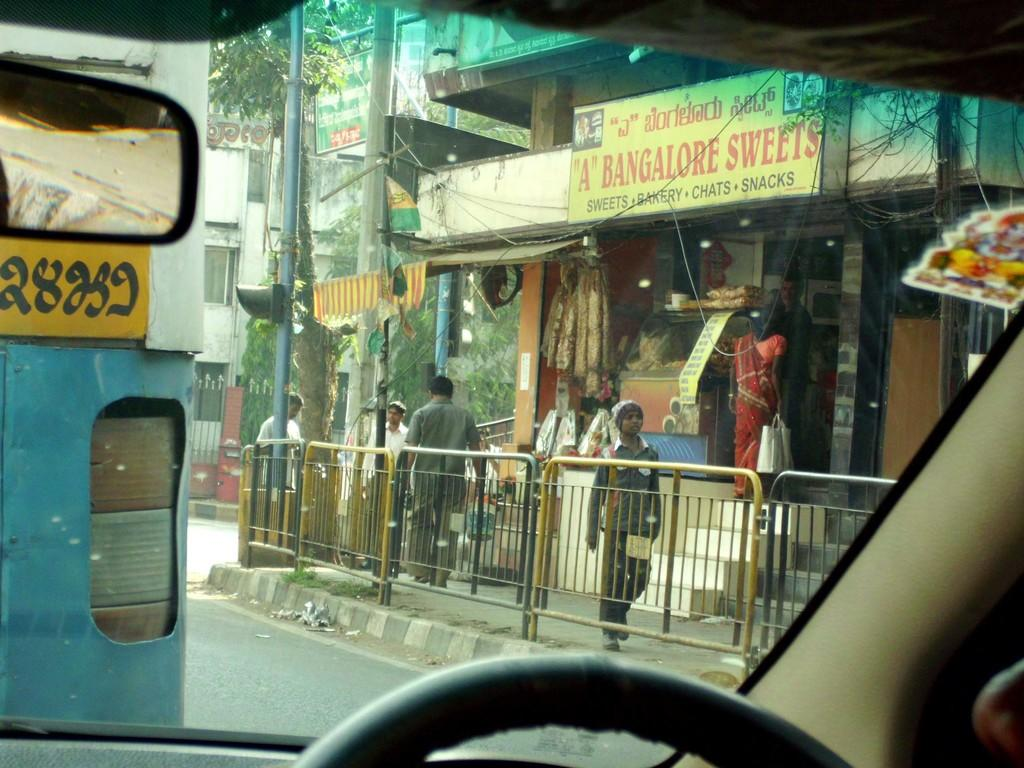What is happening on the road in the image? There are vehicles on the road in the image. What are the people in the image doing? There are people walking on a footpath in the image. What type of establishment can be seen in the image? There is a shop visible in the image. What can be observed about the buildings in the image? There are buildings with windows in the image. What type of natural element is visible in the background of the image? Trees are present in the background of the image. What type of board is being used by the girl in the image? There is no girl present in the image, and therefore no board can be observed. 